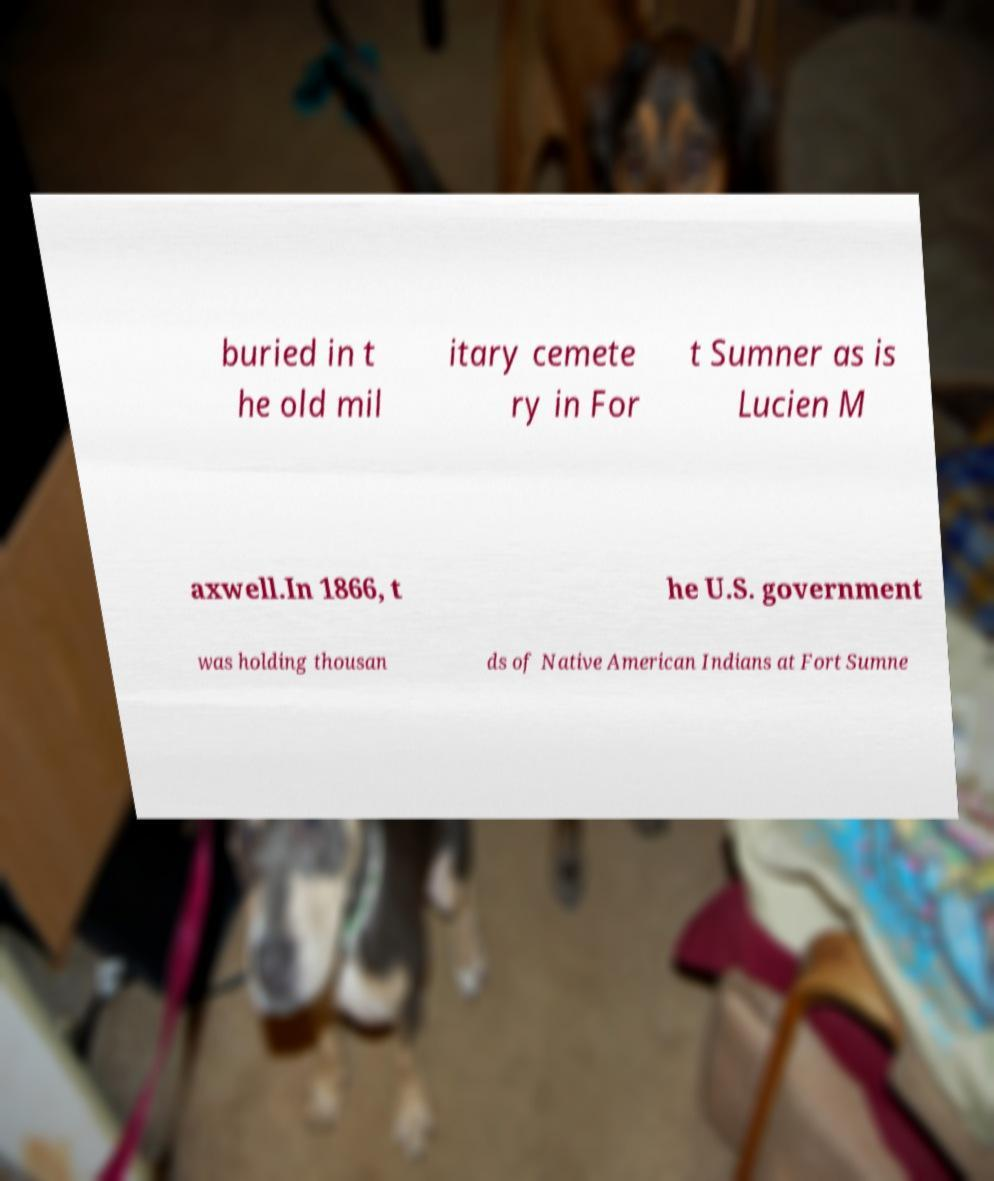Please identify and transcribe the text found in this image. buried in t he old mil itary cemete ry in For t Sumner as is Lucien M axwell.In 1866, t he U.S. government was holding thousan ds of Native American Indians at Fort Sumne 